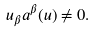Convert formula to latex. <formula><loc_0><loc_0><loc_500><loc_500>u _ { \beta } a ^ { \beta } ( u ) \ne 0 .</formula> 